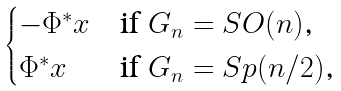Convert formula to latex. <formula><loc_0><loc_0><loc_500><loc_500>\begin{cases} - \Phi ^ { * } x & \text {if $G_{n}=SO(n)$,} \\ \Phi ^ { * } x & \text {if $G_{n}=Sp(n/2)$,} \end{cases}</formula> 